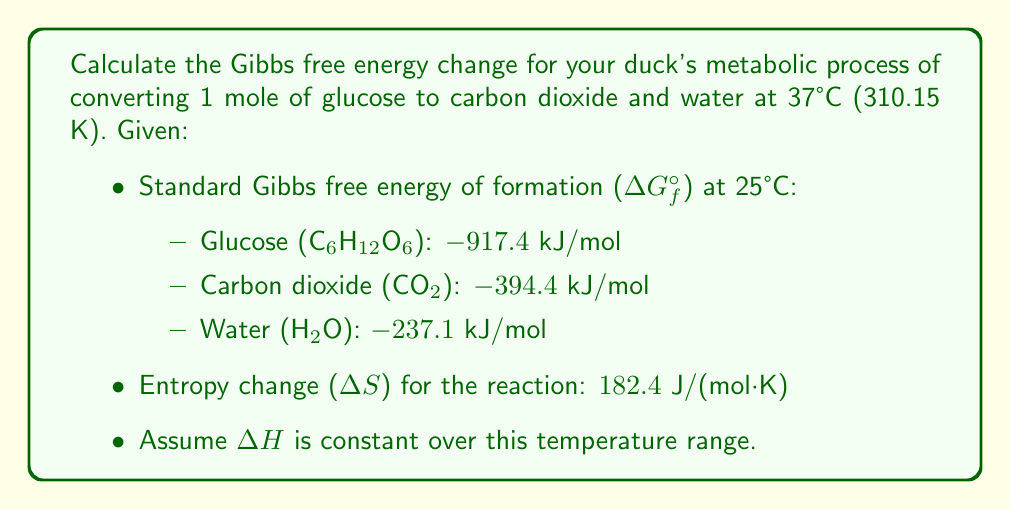Teach me how to tackle this problem. Let's approach this step-by-step:

1) First, we need to write the balanced equation for glucose oxidation:
   $$C_6H_{12}O_6 + 6O_2 \rightarrow 6CO_2 + 6H_2O$$

2) Calculate ΔG° at 25°C (298.15 K):
   $$\begin{align}
   \Delta G° &= \sum n\Delta G°f_{products} - \sum n\Delta G°f_{reactants} \\
   &= [6(-394.4) + 6(-237.1)] - [-917.4] \\
   &= -2872.2 kJ/mol
   \end{align}$$

3) To find ΔG at 37°C, we use the Gibbs-Helmholtz equation:
   $$\Delta G = \Delta H - T\Delta S$$

4) We don't have ΔH, but we can calculate it using ΔG° and ΔS at 25°C:
   $$\begin{align}
   \Delta G° &= \Delta H - T\Delta S \\
   -2872.2 &= \Delta H - 298.15 \cdot 0.1824 \\
   \Delta H &= -2872.2 + 54.38 = -2817.82 \text{ kJ/mol}
   \end{align}$$

5) Now we can calculate ΔG at 37°C (310.15 K):
   $$\begin{align}
   \Delta G_{37°C} &= \Delta H - T\Delta S \\
   &= -2817.82 - 310.15 \cdot 0.1824 \\
   &= -2817.82 - 56.57 \\
   &= -2874.39 \text{ kJ/mol}
   \end{align}$$
Answer: -2874.39 kJ/mol 